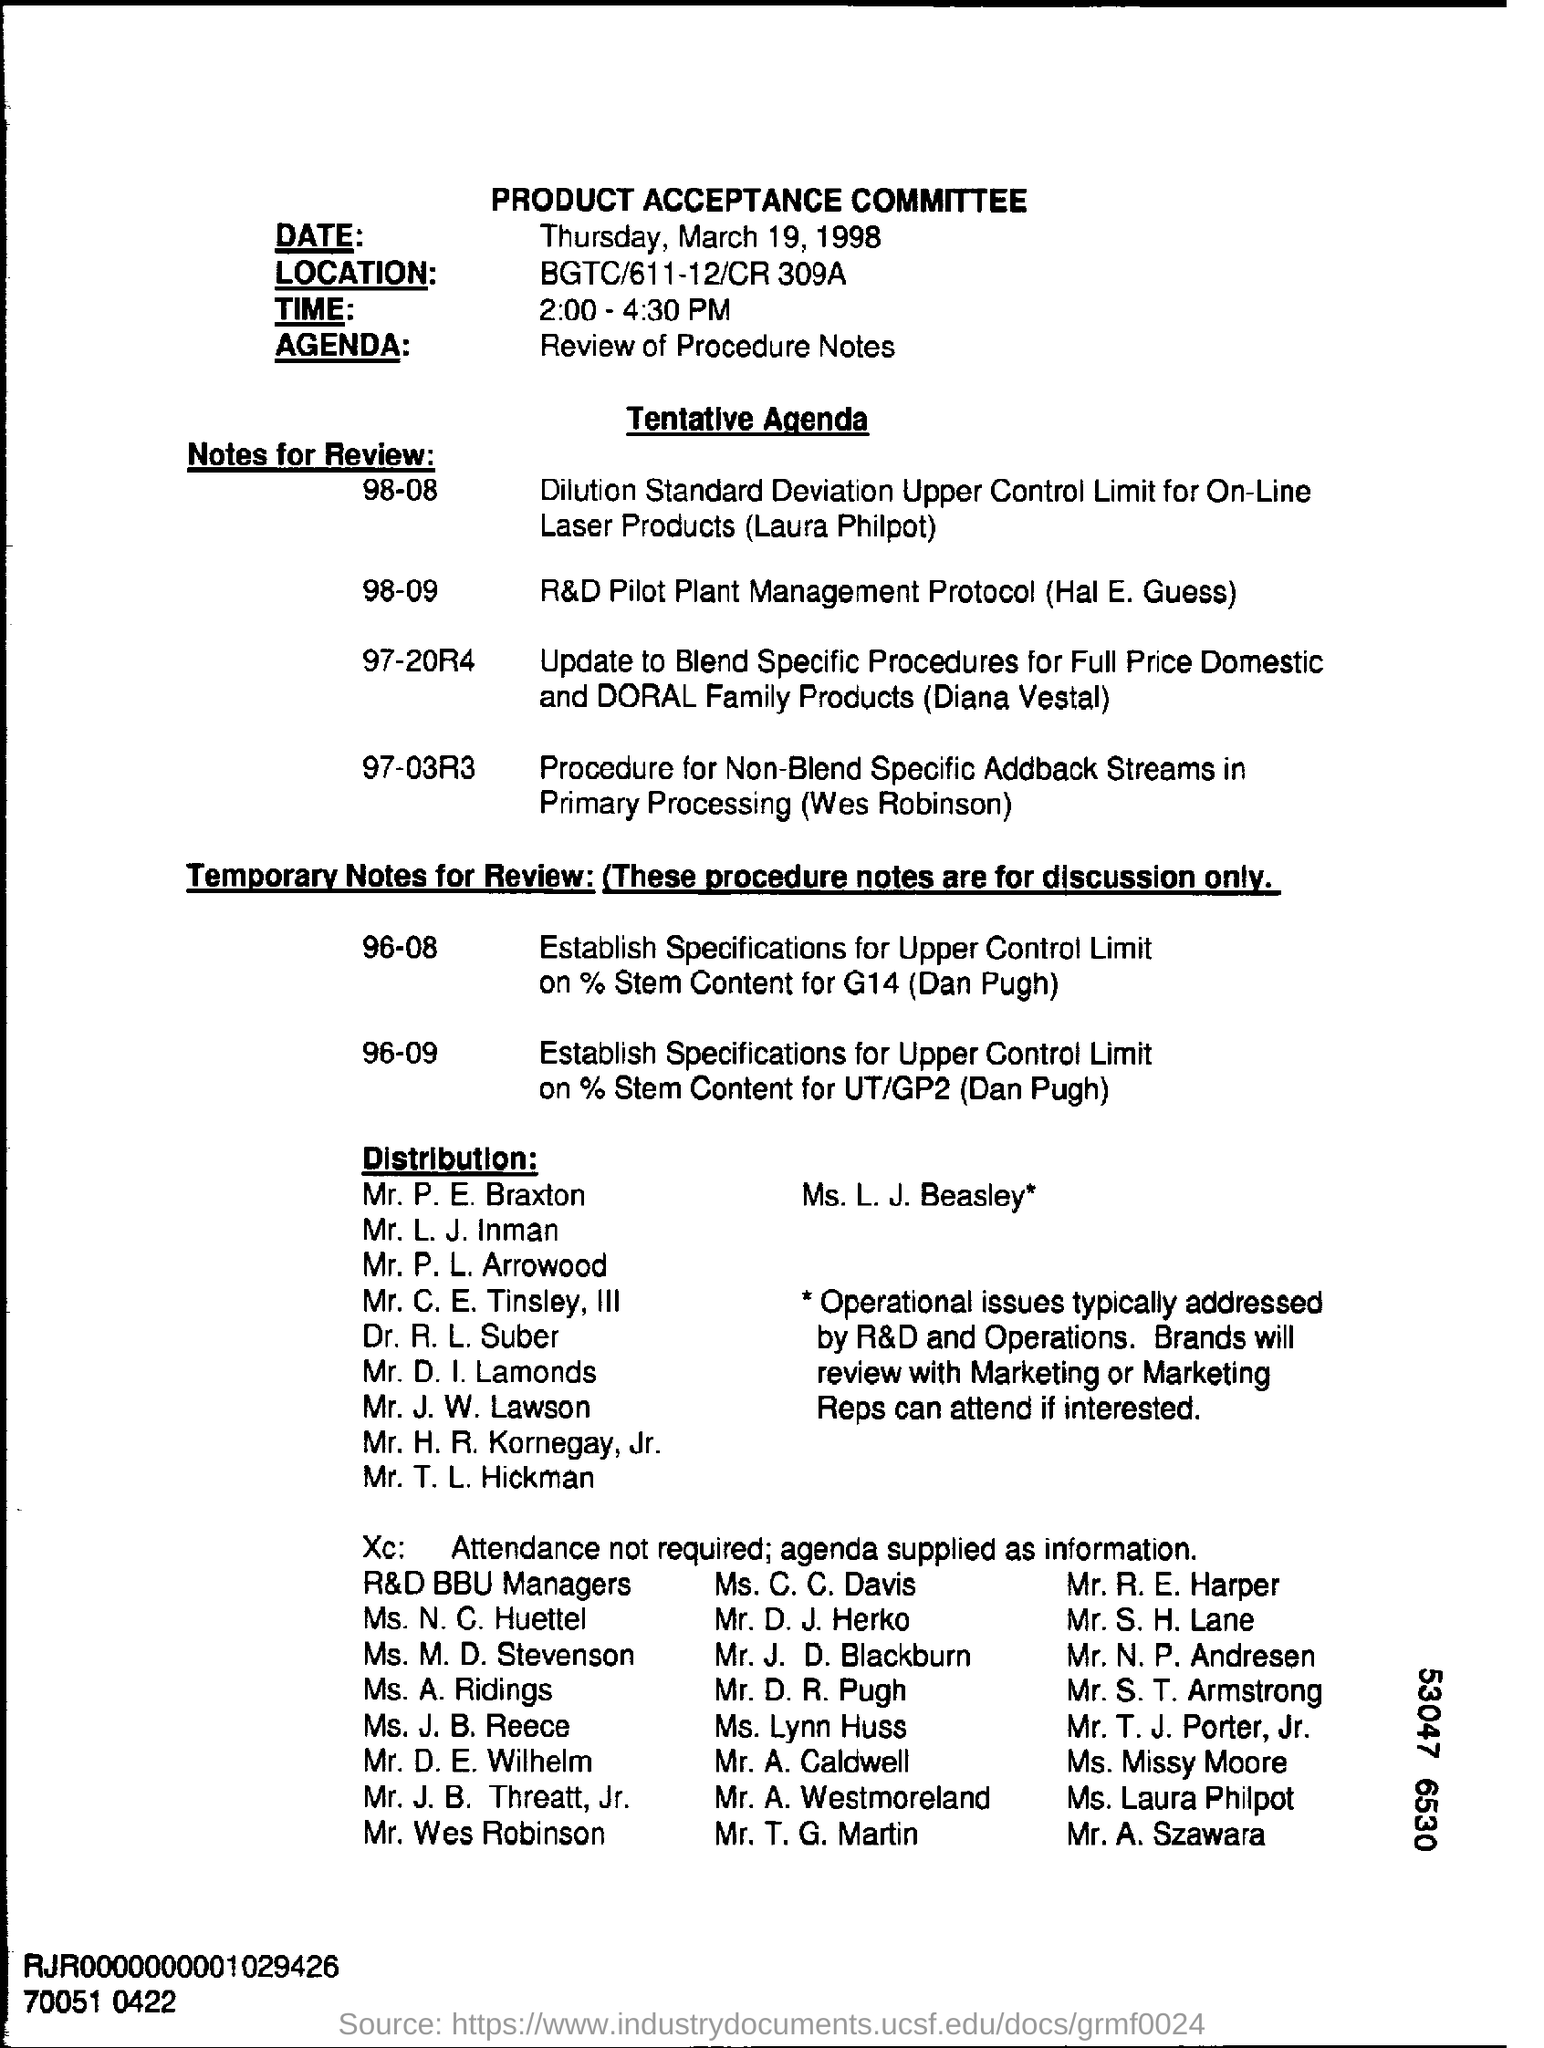What is written in the Letter Head ?
Keep it short and to the point. PRODUCT ACCEPTANCE COMMITTEE. What is the agenda of this meeting?
Provide a succinct answer. Review of Procedure Notes. Where is the Location ?
Provide a short and direct response. BGTC/611-12/CR 309A. What time is the Product Acceptance Committee Meeting scheduled?
Keep it short and to the point. 2:00 - 4:30 PM. What is written in the Agenda Field ?
Ensure brevity in your answer.  Review of Procedure Notes. 